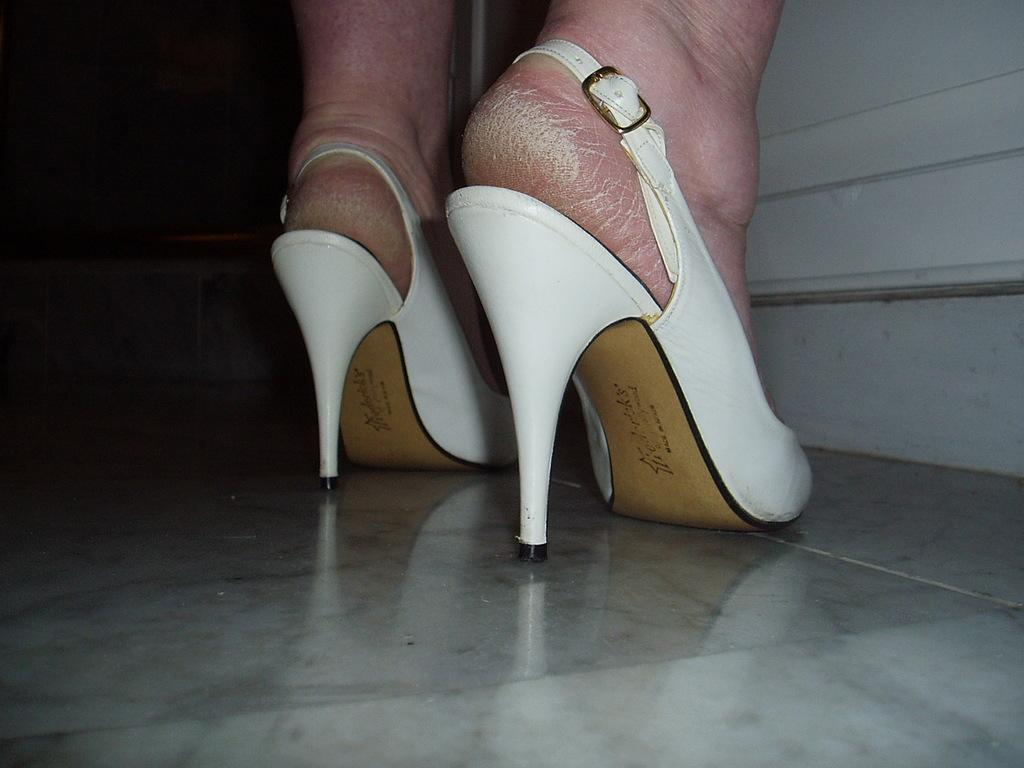What can be seen in the image related to a person's foot? There is a person's foot in the image. What is the footwear on the foot? The foot is wearing white color footwear. Can you describe the footwear further? The footwear has writing on it. Where is the foot located in the image? The foot is on a floor. What can be seen in the background of the image? There is a white wall in the background of the image. What type of zinc is being used in the meeting depicted in the image? There is no meeting or zinc present in the image; it only shows a person's foot with footwear on a floor and a white wall in the background. 